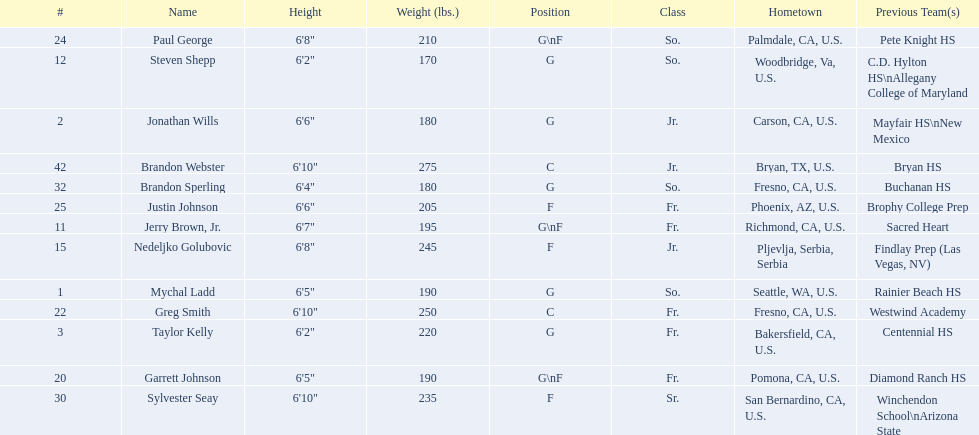What are the names for all players? Mychal Ladd, Jonathan Wills, Taylor Kelly, Jerry Brown, Jr., Steven Shepp, Nedeljko Golubovic, Garrett Johnson, Greg Smith, Paul George, Justin Johnson, Sylvester Seay, Brandon Sperling, Brandon Webster. Can you give me this table as a dict? {'header': ['#', 'Name', 'Height', 'Weight (lbs.)', 'Position', 'Class', 'Hometown', 'Previous Team(s)'], 'rows': [['24', 'Paul George', '6\'8"', '210', 'G\\nF', 'So.', 'Palmdale, CA, U.S.', 'Pete Knight HS'], ['12', 'Steven Shepp', '6\'2"', '170', 'G', 'So.', 'Woodbridge, Va, U.S.', 'C.D. Hylton HS\\nAllegany College of Maryland'], ['2', 'Jonathan Wills', '6\'6"', '180', 'G', 'Jr.', 'Carson, CA, U.S.', 'Mayfair HS\\nNew Mexico'], ['42', 'Brandon Webster', '6\'10"', '275', 'C', 'Jr.', 'Bryan, TX, U.S.', 'Bryan HS'], ['32', 'Brandon Sperling', '6\'4"', '180', 'G', 'So.', 'Fresno, CA, U.S.', 'Buchanan HS'], ['25', 'Justin Johnson', '6\'6"', '205', 'F', 'Fr.', 'Phoenix, AZ, U.S.', 'Brophy College Prep'], ['11', 'Jerry Brown, Jr.', '6\'7"', '195', 'G\\nF', 'Fr.', 'Richmond, CA, U.S.', 'Sacred Heart'], ['15', 'Nedeljko Golubovic', '6\'8"', '245', 'F', 'Jr.', 'Pljevlja, Serbia, Serbia', 'Findlay Prep (Las Vegas, NV)'], ['1', 'Mychal Ladd', '6\'5"', '190', 'G', 'So.', 'Seattle, WA, U.S.', 'Rainier Beach HS'], ['22', 'Greg Smith', '6\'10"', '250', 'C', 'Fr.', 'Fresno, CA, U.S.', 'Westwind Academy'], ['3', 'Taylor Kelly', '6\'2"', '220', 'G', 'Fr.', 'Bakersfield, CA, U.S.', 'Centennial HS'], ['20', 'Garrett Johnson', '6\'5"', '190', 'G\\nF', 'Fr.', 'Pomona, CA, U.S.', 'Diamond Ranch HS'], ['30', 'Sylvester Seay', '6\'10"', '235', 'F', 'Sr.', 'San Bernardino, CA, U.S.', 'Winchendon School\\nArizona State']]} Which players are taller than 6'8? Nedeljko Golubovic, Greg Smith, Paul George, Sylvester Seay, Brandon Webster. How tall is paul george? 6'8". How tall is greg smith? 6'10". Of these two, which it tallest? Greg Smith. 